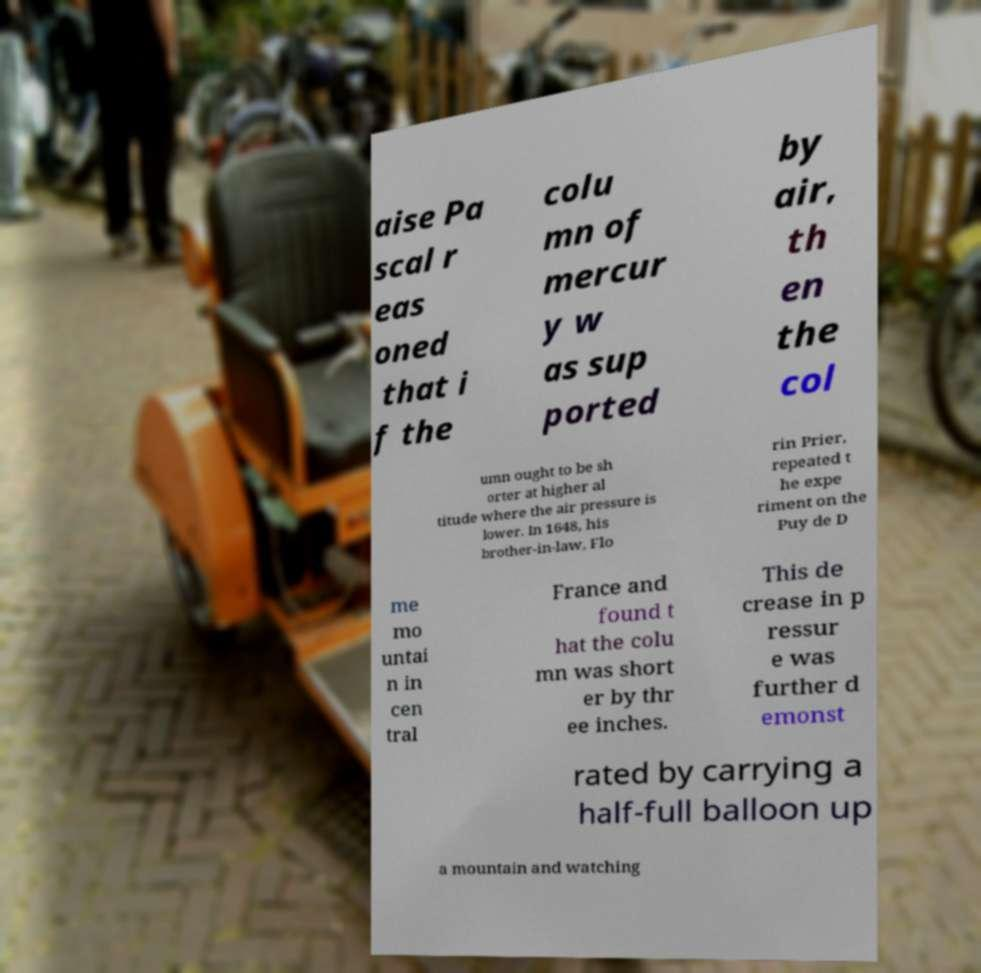I need the written content from this picture converted into text. Can you do that? aise Pa scal r eas oned that i f the colu mn of mercur y w as sup ported by air, th en the col umn ought to be sh orter at higher al titude where the air pressure is lower. In 1648, his brother-in-law, Flo rin Prier, repeated t he expe riment on the Puy de D me mo untai n in cen tral France and found t hat the colu mn was short er by thr ee inches. This de crease in p ressur e was further d emonst rated by carrying a half-full balloon up a mountain and watching 